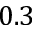<formula> <loc_0><loc_0><loc_500><loc_500>0 . 3</formula> 